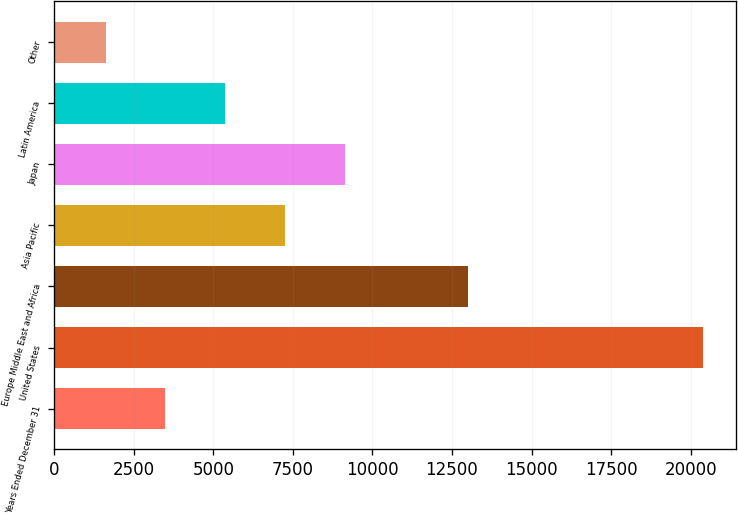Convert chart to OTSL. <chart><loc_0><loc_0><loc_500><loc_500><bar_chart><fcel>Years Ended December 31<fcel>United States<fcel>Europe Middle East and Africa<fcel>Asia Pacific<fcel>Japan<fcel>Latin America<fcel>Other<nl><fcel>3496.3<fcel>20392<fcel>12990<fcel>7250.9<fcel>9128.2<fcel>5373.6<fcel>1619<nl></chart> 